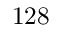Convert formula to latex. <formula><loc_0><loc_0><loc_500><loc_500>1 2 8</formula> 